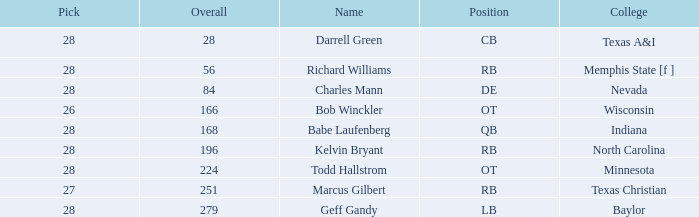In rounds beyond the first, what is the combined number of picks from texas a&i college? None. Would you mind parsing the complete table? {'header': ['Pick', 'Overall', 'Name', 'Position', 'College'], 'rows': [['28', '28', 'Darrell Green', 'CB', 'Texas A&I'], ['28', '56', 'Richard Williams', 'RB', 'Memphis State [f ]'], ['28', '84', 'Charles Mann', 'DE', 'Nevada'], ['26', '166', 'Bob Winckler', 'OT', 'Wisconsin'], ['28', '168', 'Babe Laufenberg', 'QB', 'Indiana'], ['28', '196', 'Kelvin Bryant', 'RB', 'North Carolina'], ['28', '224', 'Todd Hallstrom', 'OT', 'Minnesota'], ['27', '251', 'Marcus Gilbert', 'RB', 'Texas Christian'], ['28', '279', 'Geff Gandy', 'LB', 'Baylor']]} 